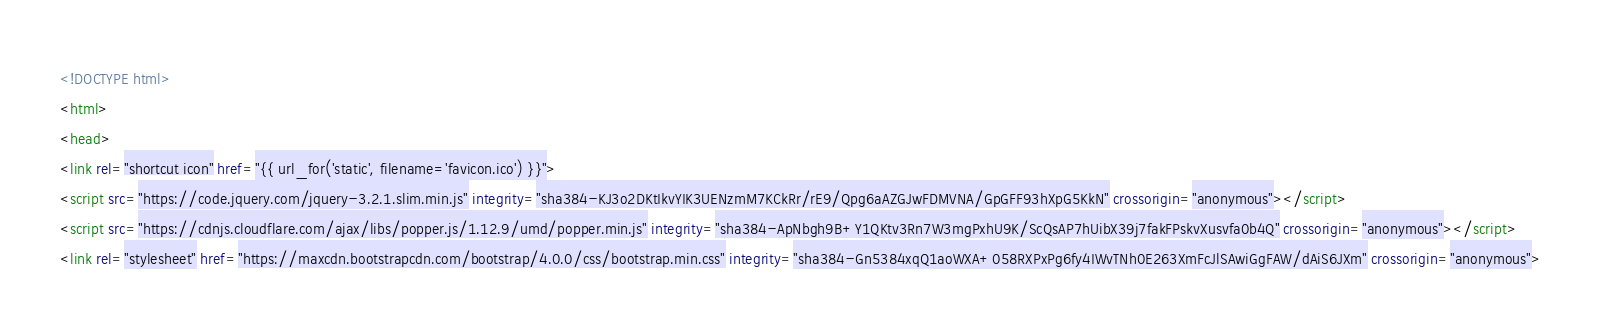<code> <loc_0><loc_0><loc_500><loc_500><_HTML_><!DOCTYPE html>
<html>
<head>
<link rel="shortcut icon" href="{{ url_for('static', filename='favicon.ico') }}">
<script src="https://code.jquery.com/jquery-3.2.1.slim.min.js" integrity="sha384-KJ3o2DKtIkvYIK3UENzmM7KCkRr/rE9/Qpg6aAZGJwFDMVNA/GpGFF93hXpG5KkN" crossorigin="anonymous"></script>
<script src="https://cdnjs.cloudflare.com/ajax/libs/popper.js/1.12.9/umd/popper.min.js" integrity="sha384-ApNbgh9B+Y1QKtv3Rn7W3mgPxhU9K/ScQsAP7hUibX39j7fakFPskvXusvfa0b4Q" crossorigin="anonymous"></script>
<link rel="stylesheet" href="https://maxcdn.bootstrapcdn.com/bootstrap/4.0.0/css/bootstrap.min.css" integrity="sha384-Gn5384xqQ1aoWXA+058RXPxPg6fy4IWvTNh0E263XmFcJlSAwiGgFAW/dAiS6JXm" crossorigin="anonymous"></code> 